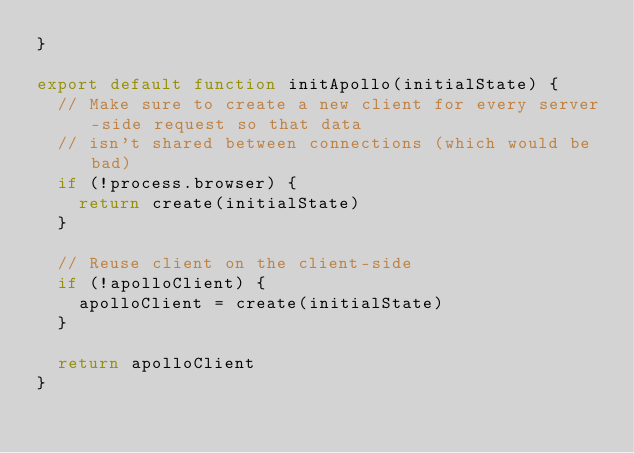<code> <loc_0><loc_0><loc_500><loc_500><_JavaScript_>}

export default function initApollo(initialState) {
  // Make sure to create a new client for every server-side request so that data
  // isn't shared between connections (which would be bad)
  if (!process.browser) {
    return create(initialState)
  }

  // Reuse client on the client-side
  if (!apolloClient) {
    apolloClient = create(initialState)
  }

  return apolloClient
}</code> 